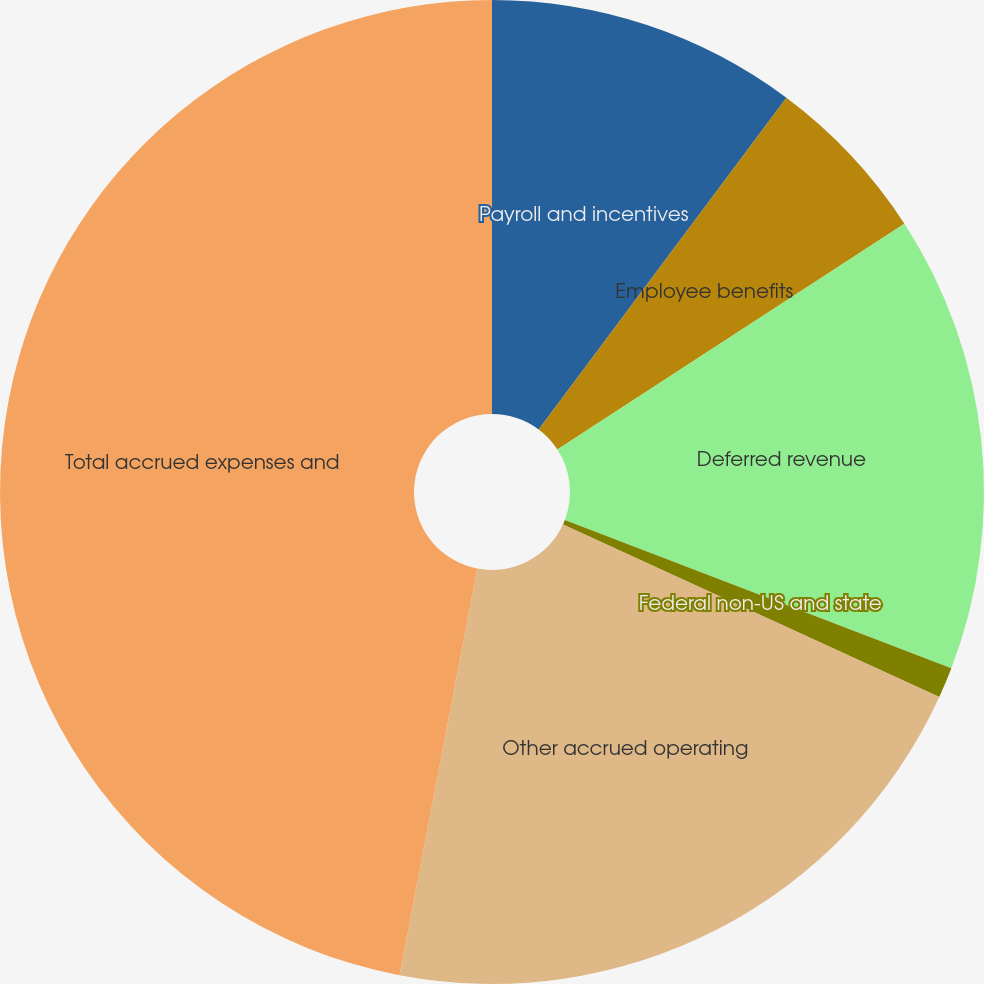Convert chart. <chart><loc_0><loc_0><loc_500><loc_500><pie_chart><fcel>Payroll and incentives<fcel>Employee benefits<fcel>Deferred revenue<fcel>Federal non-US and state<fcel>Other accrued operating<fcel>Total accrued expenses and<nl><fcel>10.21%<fcel>5.61%<fcel>15.01%<fcel>1.01%<fcel>21.17%<fcel>46.99%<nl></chart> 